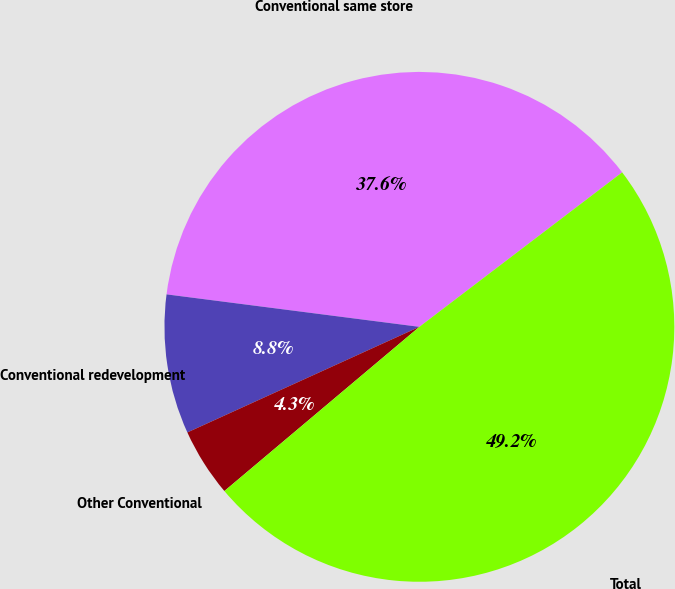<chart> <loc_0><loc_0><loc_500><loc_500><pie_chart><fcel>Conventional same store<fcel>Conventional redevelopment<fcel>Other Conventional<fcel>Total<nl><fcel>37.6%<fcel>8.83%<fcel>4.34%<fcel>49.22%<nl></chart> 